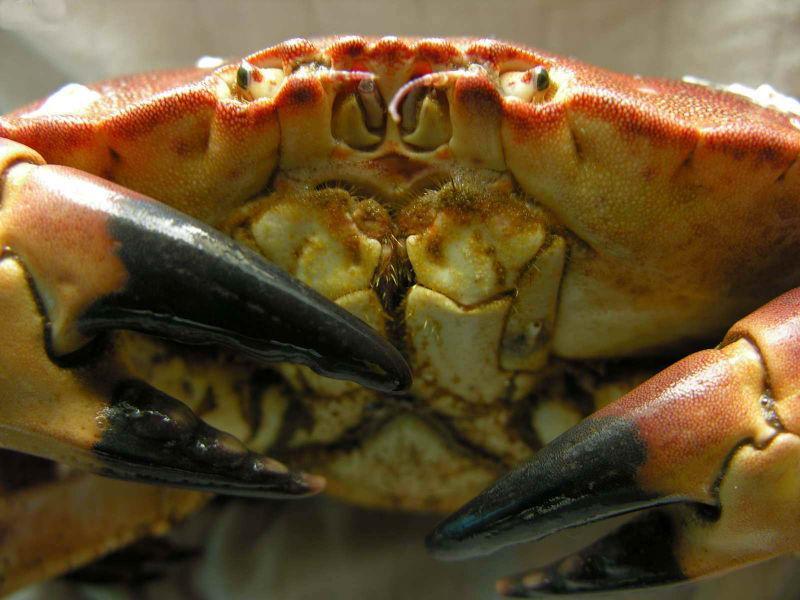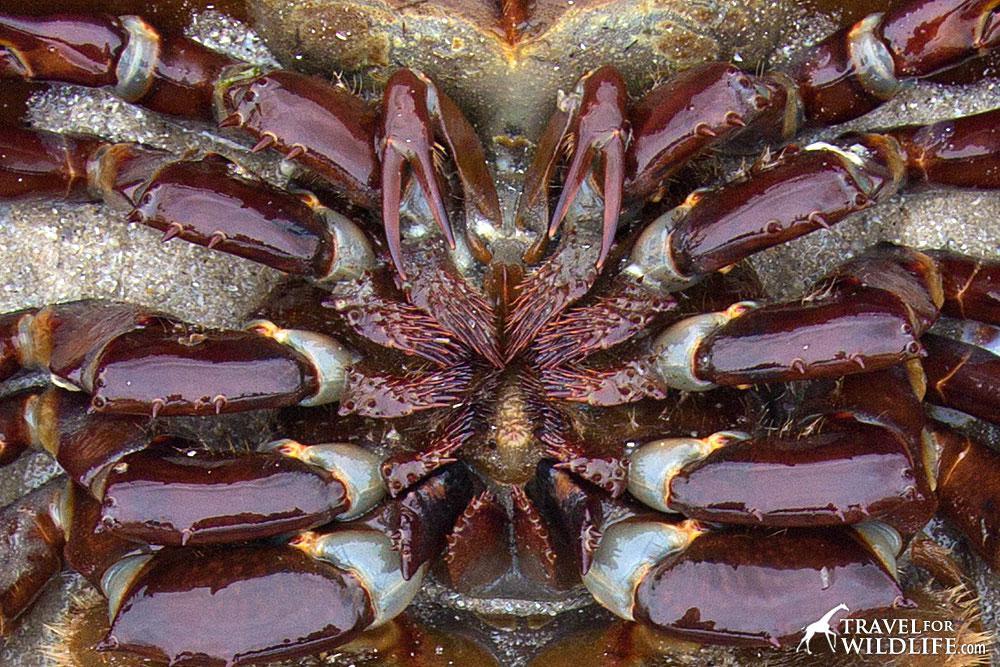The first image is the image on the left, the second image is the image on the right. Assess this claim about the two images: "In one of the images, the underbelly of a crab is shown.". Correct or not? Answer yes or no. Yes. The first image is the image on the left, the second image is the image on the right. For the images displayed, is the sentence "One image shows the underside of a crab, and the other image shows a face-forward crab with eyes visible." factually correct? Answer yes or no. Yes. 